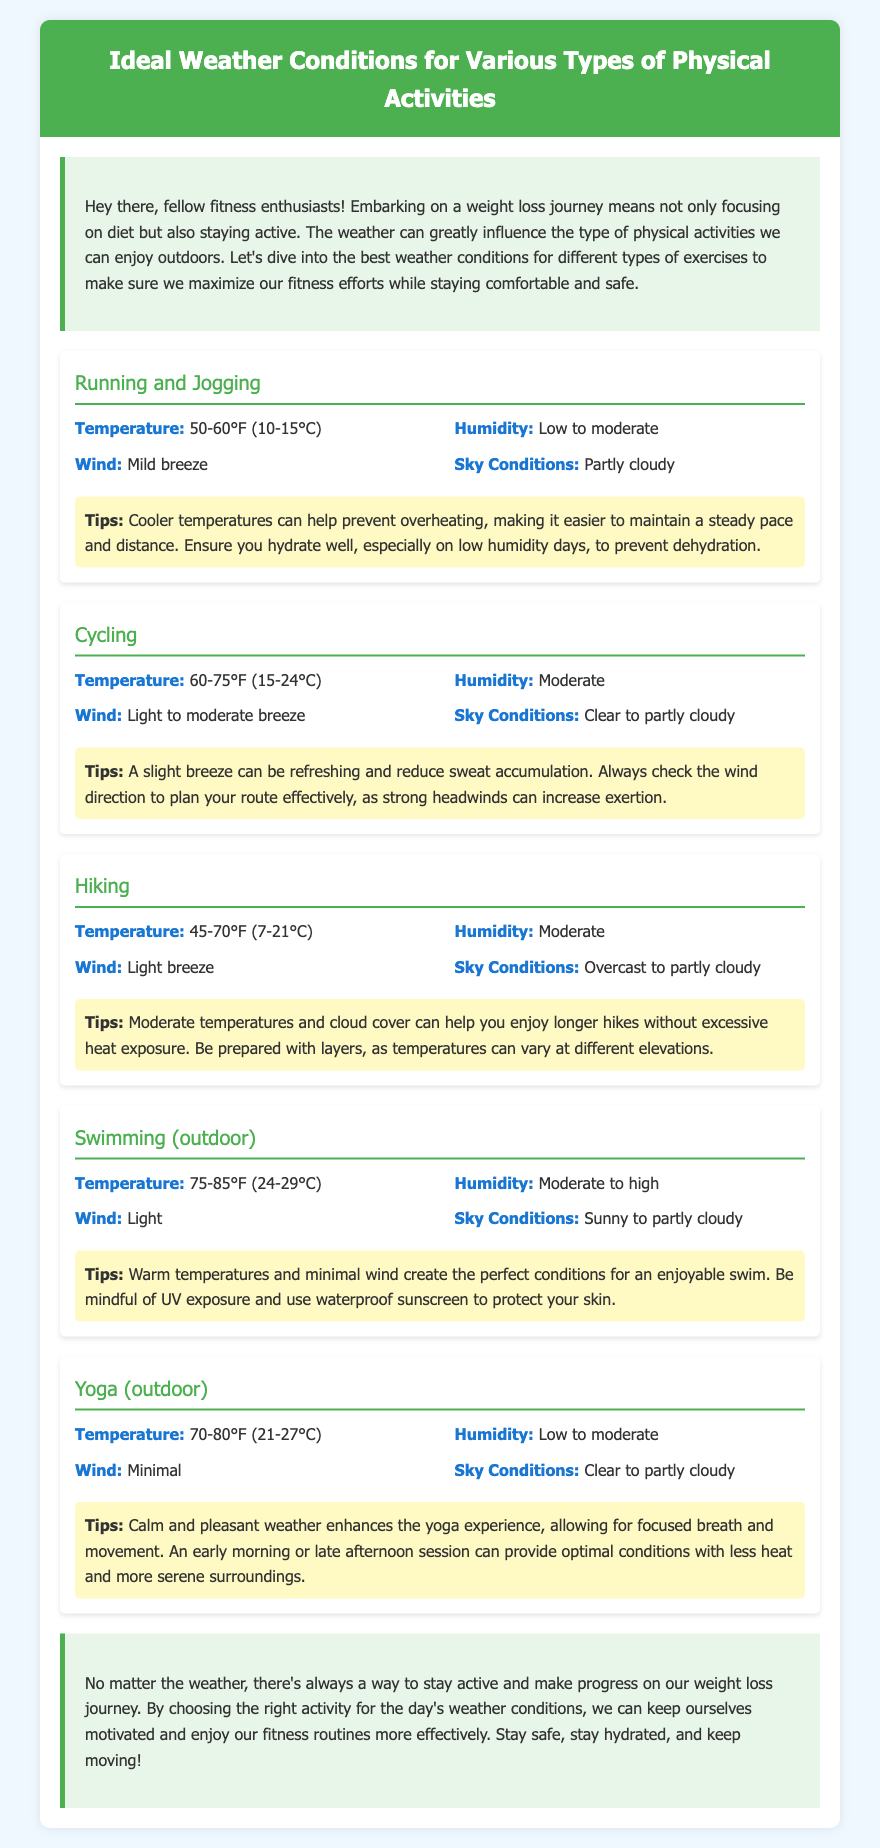What is the ideal temperature for running and jogging? The ideal temperature for running and jogging is specified in the document.
Answer: 50-60°F (10-15°C) What humidity level is recommended for cycling? The document specifies the recommended humidity level for cycling in the weather details section.
Answer: Moderate What sky condition is ideal for swimming outdoors? The document mentions the ideal sky conditions for outdoor swimming.
Answer: Sunny to partly cloudy What is the preferred temperature range for yoga? The document includes the preferred temperature range for outdoor yoga activities.
Answer: 70-80°F (21-27°C) How does a light breeze affect cycling? The document discusses the effects of light breezes on cycling performance in the tips section.
Answer: Refreshing and reduces sweat accumulation What temperature range is ideal for hiking activities? The document provides the temperature range ideal for hiking activities.
Answer: 45-70°F (7-21°C) What should you be cautious of while swimming? The tips section of the swimming activity discusses precautions to take during swimming.
Answer: UV exposure What type of breeze is recommended for running? The document details the wind recommendations for running and jogging activities.
Answer: Mild breeze Which weather condition is optimal for a long hike? The document mentions the weather condition that makes hiking enjoyable.
Answer: Overcast to partly cloudy 